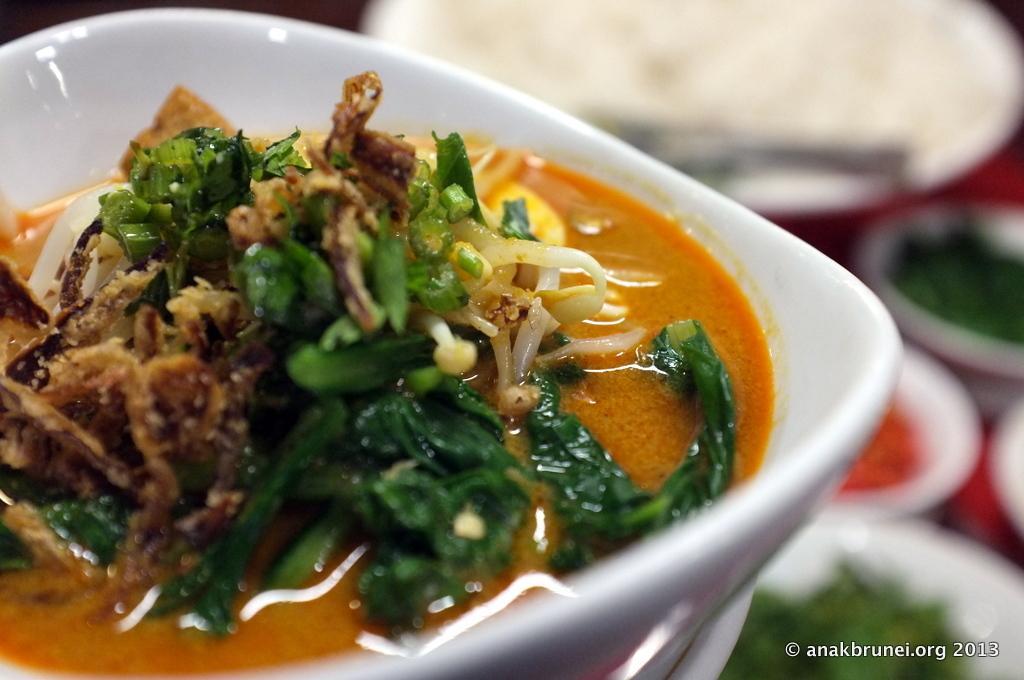Could you give a brief overview of what you see in this image? In this image I can see white colour plate and in it I can see different types of food. I can also see few other things in background and I can see this image is little bit blurry from background. Here I can see watermark. 